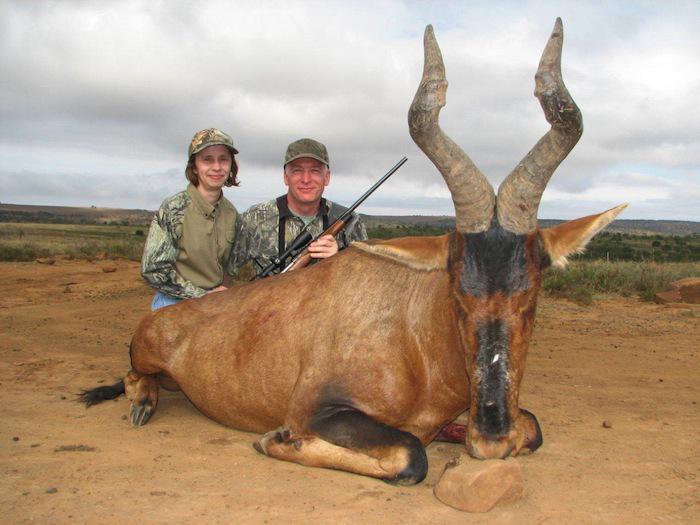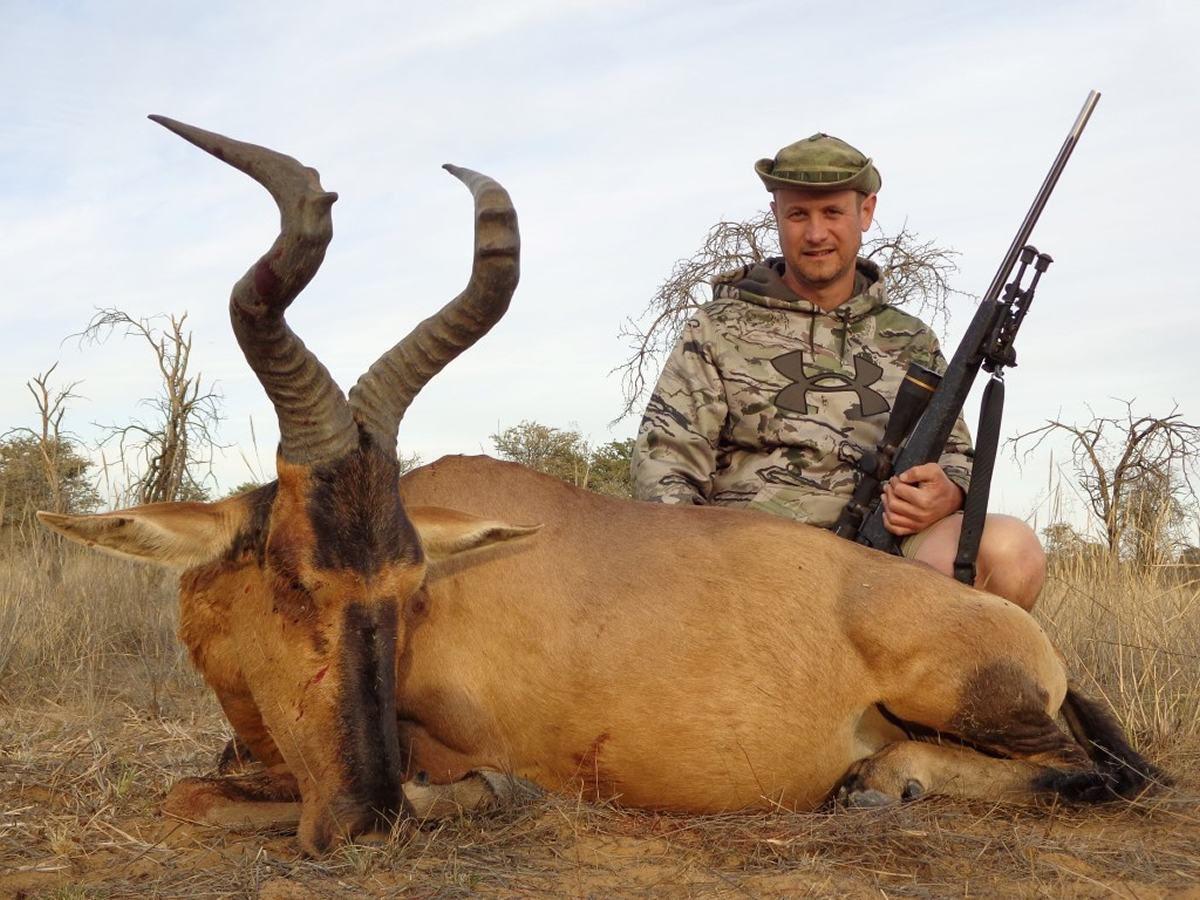The first image is the image on the left, the second image is the image on the right. For the images shown, is this caption "At least one live ibex is standing in the grass and weeds." true? Answer yes or no. No. The first image is the image on the left, the second image is the image on the right. Examine the images to the left and right. Is the description "An image shows a hunter holding a rifle crouched behind a downed horned animal with its body facing leftward and its head turned forward, nose on the ground." accurate? Answer yes or no. Yes. 